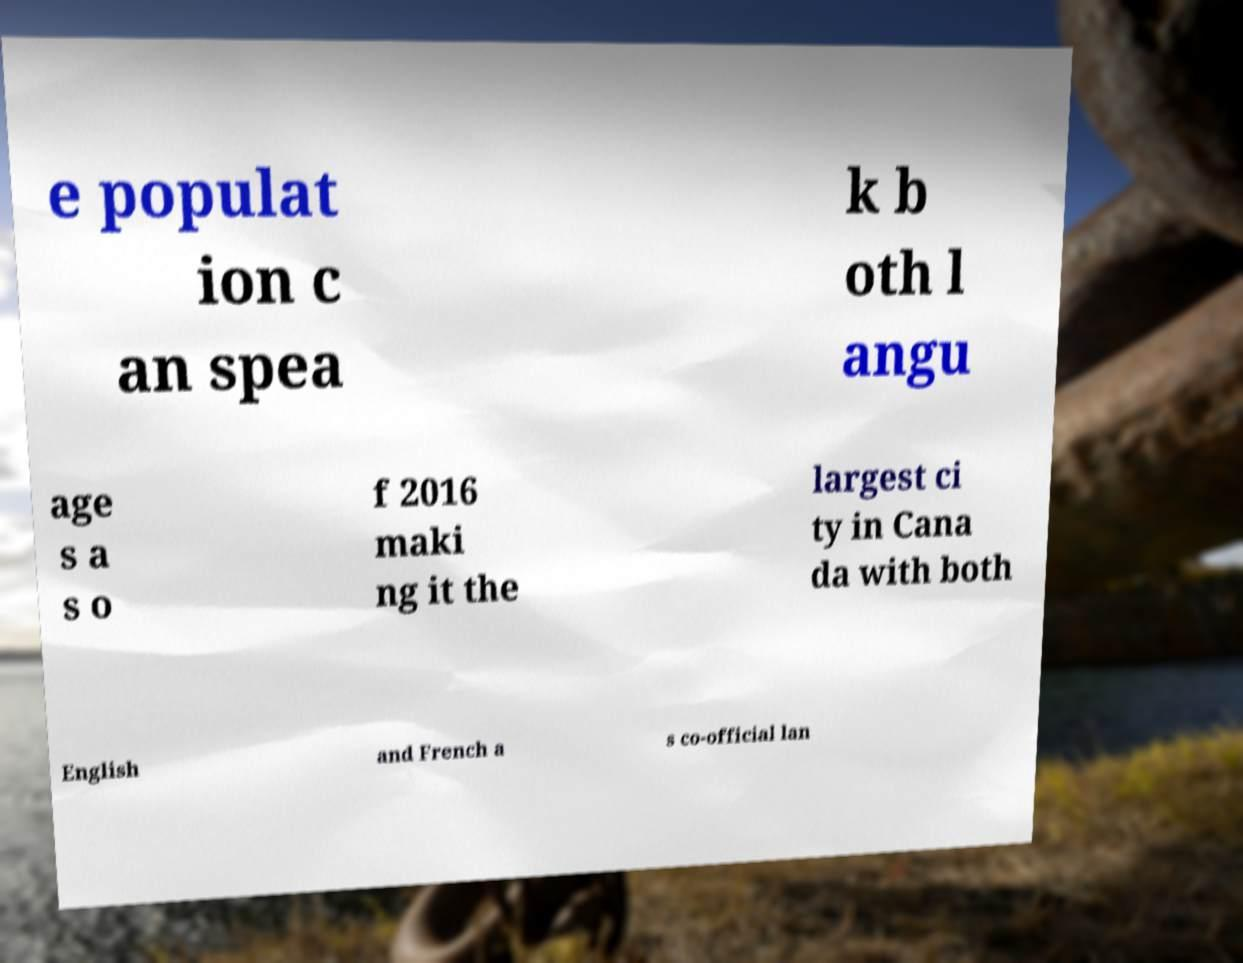What messages or text are displayed in this image? I need them in a readable, typed format. e populat ion c an spea k b oth l angu age s a s o f 2016 maki ng it the largest ci ty in Cana da with both English and French a s co-official lan 